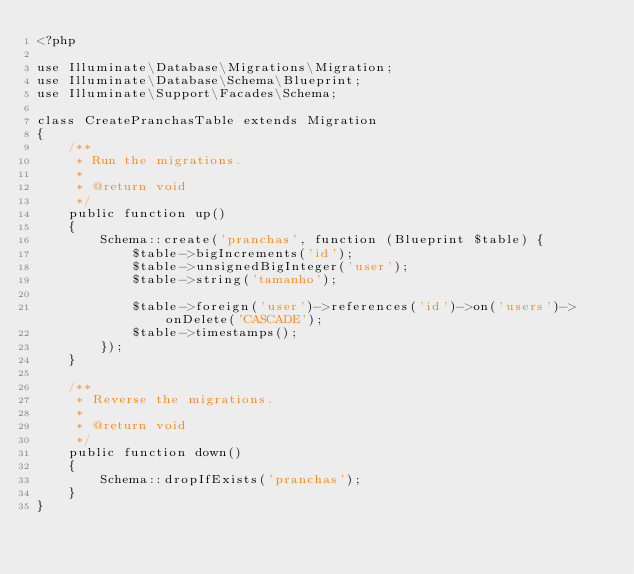Convert code to text. <code><loc_0><loc_0><loc_500><loc_500><_PHP_><?php

use Illuminate\Database\Migrations\Migration;
use Illuminate\Database\Schema\Blueprint;
use Illuminate\Support\Facades\Schema;

class CreatePranchasTable extends Migration
{
    /**
     * Run the migrations.
     *
     * @return void
     */
    public function up()
    {
        Schema::create('pranchas', function (Blueprint $table) {
            $table->bigIncrements('id');
            $table->unsignedBigInteger('user');
            $table->string('tamanho');

            $table->foreign('user')->references('id')->on('users')->onDelete('CASCADE');
            $table->timestamps();
        });
    }

    /**
     * Reverse the migrations.
     *
     * @return void
     */
    public function down()
    {
        Schema::dropIfExists('pranchas');
    }
}
</code> 